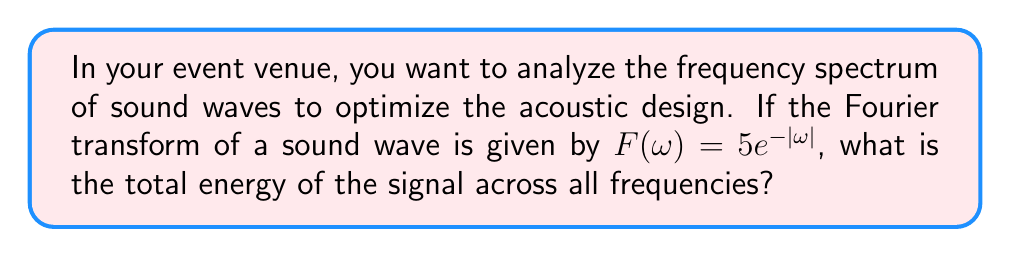Can you answer this question? To find the total energy of the signal, we need to calculate the integral of the squared magnitude of the Fourier transform over all frequencies. This is known as Parseval's theorem.

Step 1: Express the energy integral
$$E = \frac{1}{2\pi} \int_{-\infty}^{\infty} |F(\omega)|^2 d\omega$$

Step 2: Substitute the given Fourier transform
$$E = \frac{1}{2\pi} \int_{-\infty}^{\infty} |5e^{-|\omega|}|^2 d\omega$$

Step 3: Simplify the integrand
$$E = \frac{25}{2\pi} \int_{-\infty}^{\infty} e^{-2|\omega|} d\omega$$

Step 4: Split the integral due to the absolute value
$$E = \frac{25}{2\pi} \left(\int_{-\infty}^{0} e^{2\omega} d\omega + \int_{0}^{\infty} e^{-2\omega} d\omega\right)$$

Step 5: Evaluate the integrals
$$E = \frac{25}{2\pi} \left[\frac{1}{2}e^{2\omega}\Big|_{-\infty}^{0} - \frac{1}{2}e^{-2\omega}\Big|_{0}^{\infty}\right]$$
$$E = \frac{25}{2\pi} \left[\frac{1}{2} - 0 + \frac{1}{2} - 0\right] = \frac{25}{2\pi}$$

Step 6: Simplify
$$E = \frac{25}{2\pi} = \frac{25}{2\pi} \cdot \frac{\pi}{\pi} = \frac{25\pi}{2\pi^2} = \frac{25}{2\pi}$$
Answer: $\frac{25}{2\pi}$ 